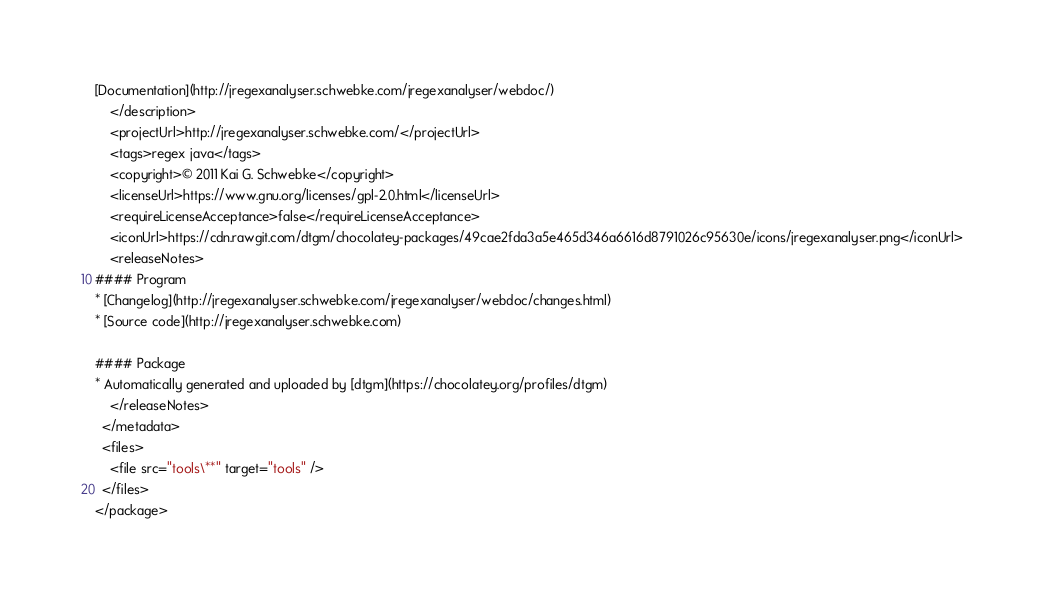Convert code to text. <code><loc_0><loc_0><loc_500><loc_500><_XML_>[Documentation](http://jregexanalyser.schwebke.com/jregexanalyser/webdoc/)
    </description>
    <projectUrl>http://jregexanalyser.schwebke.com/</projectUrl>
    <tags>regex java</tags>
    <copyright>© 2011 Kai G. Schwebke</copyright>
    <licenseUrl>https://www.gnu.org/licenses/gpl-2.0.html</licenseUrl>
    <requireLicenseAcceptance>false</requireLicenseAcceptance>
    <iconUrl>https://cdn.rawgit.com/dtgm/chocolatey-packages/49cae2fda3a5e465d346a6616d8791026c95630e/icons/jregexanalyser.png</iconUrl>
    <releaseNotes>
#### Program
* [Changelog](http://jregexanalyser.schwebke.com/jregexanalyser/webdoc/changes.html)
* [Source code](http://jregexanalyser.schwebke.com)

#### Package
* Automatically generated and uploaded by [dtgm](https://chocolatey.org/profiles/dtgm)
    </releaseNotes>
  </metadata>
  <files>
    <file src="tools\**" target="tools" />
  </files>
</package></code> 